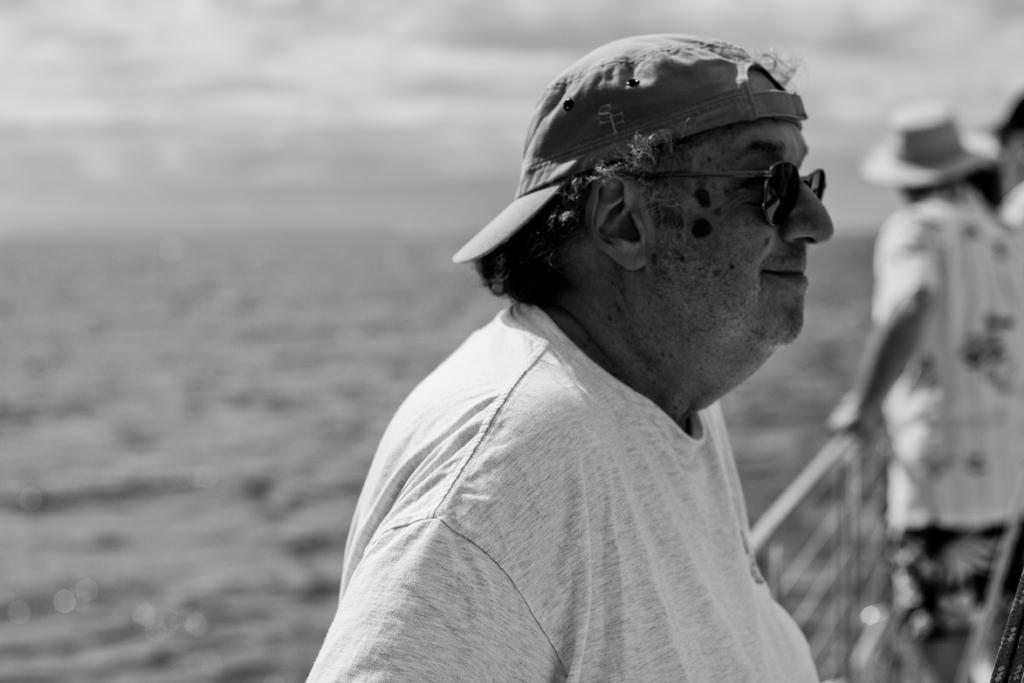Could you give a brief overview of what you see in this image? In the foreground of this black and white image, there is a man standing, wearing a cap and spectacles. In the background, there are persons standing near railing and we can also see water, sky and the cloud. 